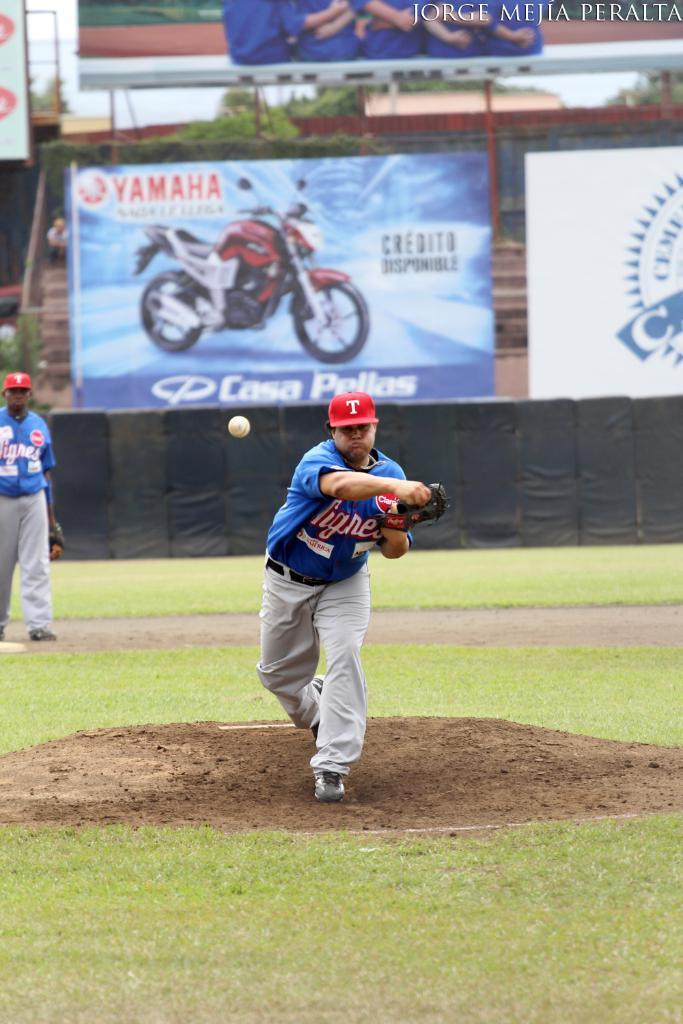<image>
Offer a succinct explanation of the picture presented. A Yamaha billboard is visible as a pitcher throws a baseball. 